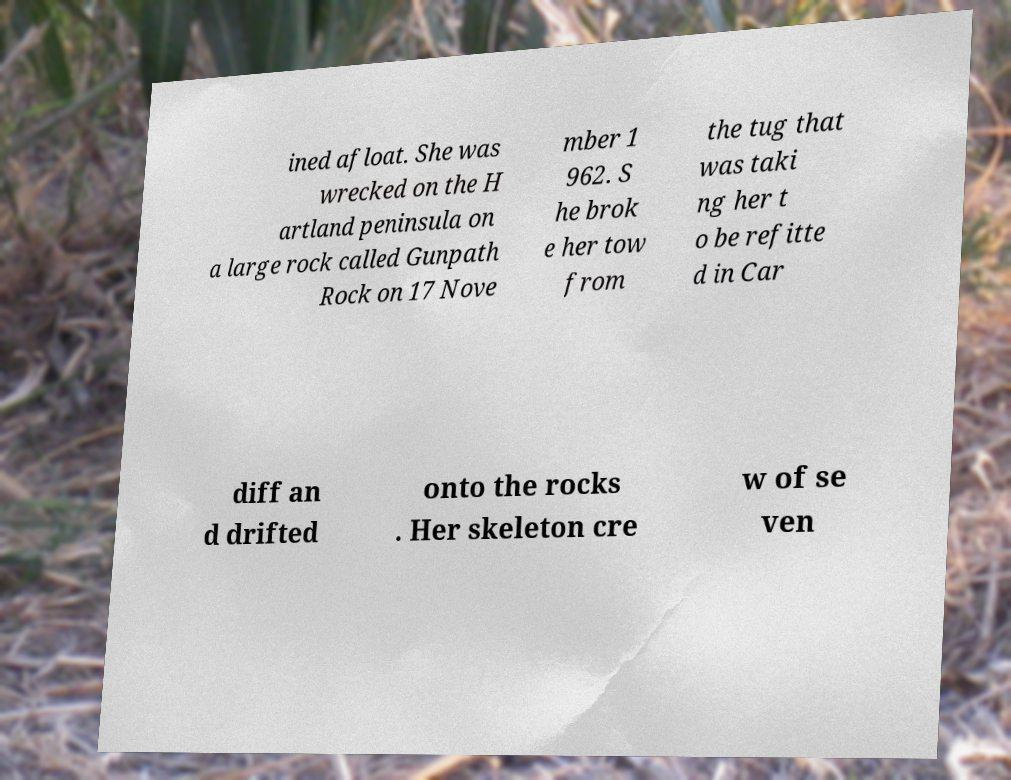Can you accurately transcribe the text from the provided image for me? ined afloat. She was wrecked on the H artland peninsula on a large rock called Gunpath Rock on 17 Nove mber 1 962. S he brok e her tow from the tug that was taki ng her t o be refitte d in Car diff an d drifted onto the rocks . Her skeleton cre w of se ven 